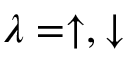Convert formula to latex. <formula><loc_0><loc_0><loc_500><loc_500>\lambda = \uparrow , \downarrow</formula> 